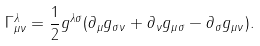Convert formula to latex. <formula><loc_0><loc_0><loc_500><loc_500>\Gamma ^ { \lambda } _ { \mu \nu } = \frac { 1 } { 2 } g ^ { \lambda \sigma } ( \partial _ { \mu } g _ { \sigma \nu } + \partial _ { \nu } g _ { \mu \sigma } - \partial _ { \sigma } g _ { \mu \nu } ) .</formula> 